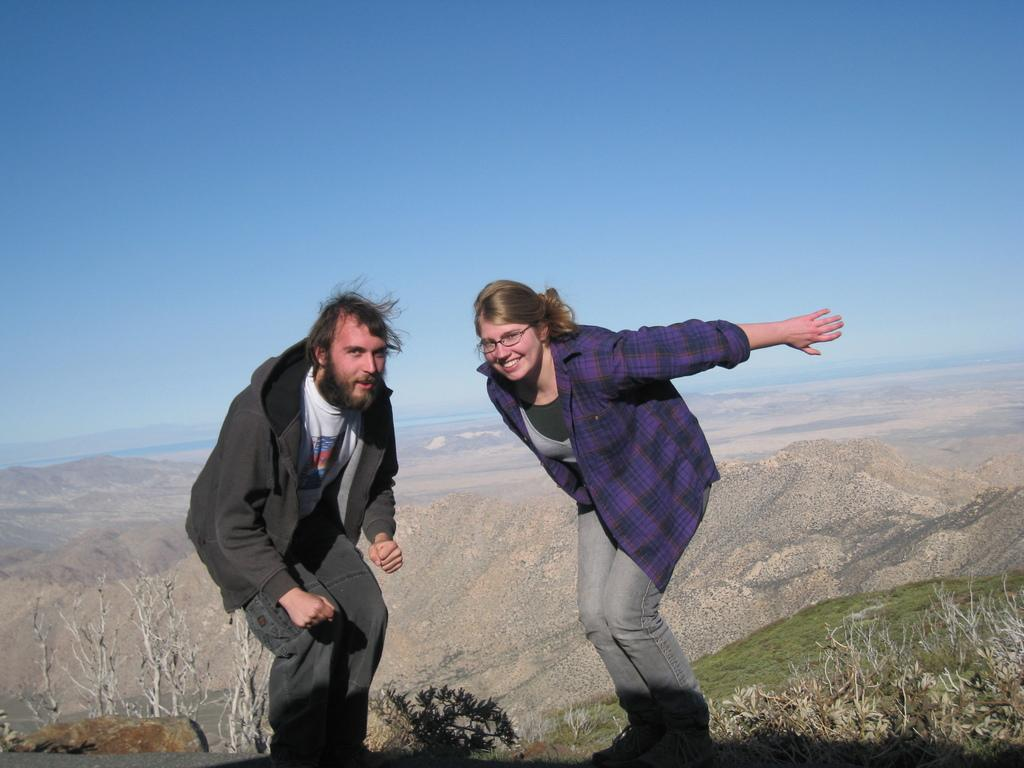How many people are in the image? There are two people in the image, a man and a woman. What are the expressions of the people in the image? Both the man and woman are smiling in the image. What accessory is the woman wearing? The woman is wearing spectacles in the image. What can be seen in the background of the image? There are trees in the background of the image. What type of honey is being used in the image? There is no honey present in the image. 